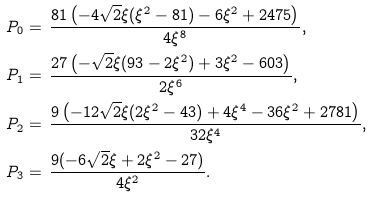<formula> <loc_0><loc_0><loc_500><loc_500>P _ { 0 } & = \, \frac { 8 1 \left ( - 4 \sqrt { 2 } \xi ( { \xi } ^ { 2 } - 8 1 ) - 6 { \xi } ^ { 2 } + 2 4 7 5 \right ) } { 4 { \xi } ^ { 8 } } , \\ P _ { 1 } & = \, \frac { 2 7 \left ( - \sqrt { 2 } \xi ( 9 3 - 2 { \xi } ^ { 2 } ) + 3 { \xi } ^ { 2 } - 6 0 3 \right ) } { 2 { \xi } ^ { 6 } } , \\ P _ { 2 } & = \, \frac { 9 \left ( - 1 2 \sqrt { 2 } \xi ( 2 { \xi } ^ { 2 } - 4 3 ) + 4 { \xi } ^ { 4 } - 3 6 { \xi } ^ { 2 } + 2 7 8 1 \right ) } { 3 2 { \xi } ^ { 4 } } , \\ P _ { 3 } & = \, \frac { 9 ( - 6 \sqrt { 2 } \xi + 2 { \xi } ^ { 2 } - 2 7 ) } { 4 { \xi } ^ { 2 } } .</formula> 